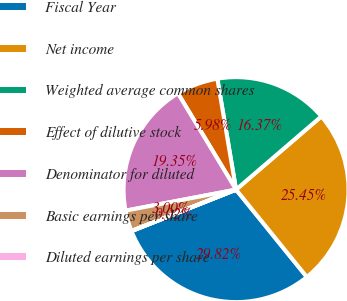Convert chart to OTSL. <chart><loc_0><loc_0><loc_500><loc_500><pie_chart><fcel>Fiscal Year<fcel>Net income<fcel>Weighted average common shares<fcel>Effect of dilutive stock<fcel>Denominator for diluted<fcel>Basic earnings per share<fcel>Diluted earnings per share<nl><fcel>29.82%<fcel>25.45%<fcel>16.37%<fcel>5.98%<fcel>19.35%<fcel>3.0%<fcel>0.02%<nl></chart> 